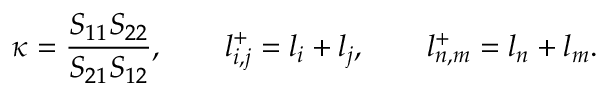Convert formula to latex. <formula><loc_0><loc_0><loc_500><loc_500>\kappa = \frac { S _ { 1 1 } S _ { 2 2 } } { S _ { 2 1 } S _ { 1 2 } } , \quad l _ { i , j } ^ { + } = l _ { i } + l _ { j } , \quad l _ { n , m } ^ { + } = l _ { n } + l _ { m } .</formula> 